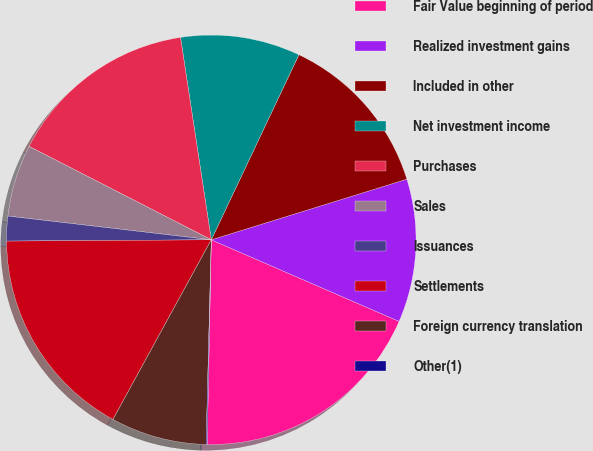<chart> <loc_0><loc_0><loc_500><loc_500><pie_chart><fcel>Fair Value beginning of period<fcel>Realized investment gains<fcel>Included in other<fcel>Net investment income<fcel>Purchases<fcel>Sales<fcel>Issuances<fcel>Settlements<fcel>Foreign currency translation<fcel>Other(1)<nl><fcel>18.8%<fcel>11.31%<fcel>13.18%<fcel>9.44%<fcel>15.06%<fcel>5.69%<fcel>1.95%<fcel>16.93%<fcel>7.57%<fcel>0.08%<nl></chart> 